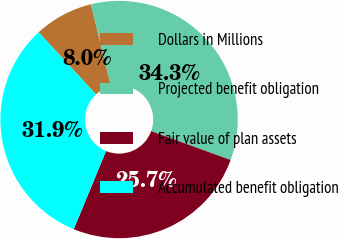Convert chart. <chart><loc_0><loc_0><loc_500><loc_500><pie_chart><fcel>Dollars in Millions<fcel>Projected benefit obligation<fcel>Fair value of plan assets<fcel>Accumulated benefit obligation<nl><fcel>8.04%<fcel>34.35%<fcel>25.7%<fcel>31.91%<nl></chart> 